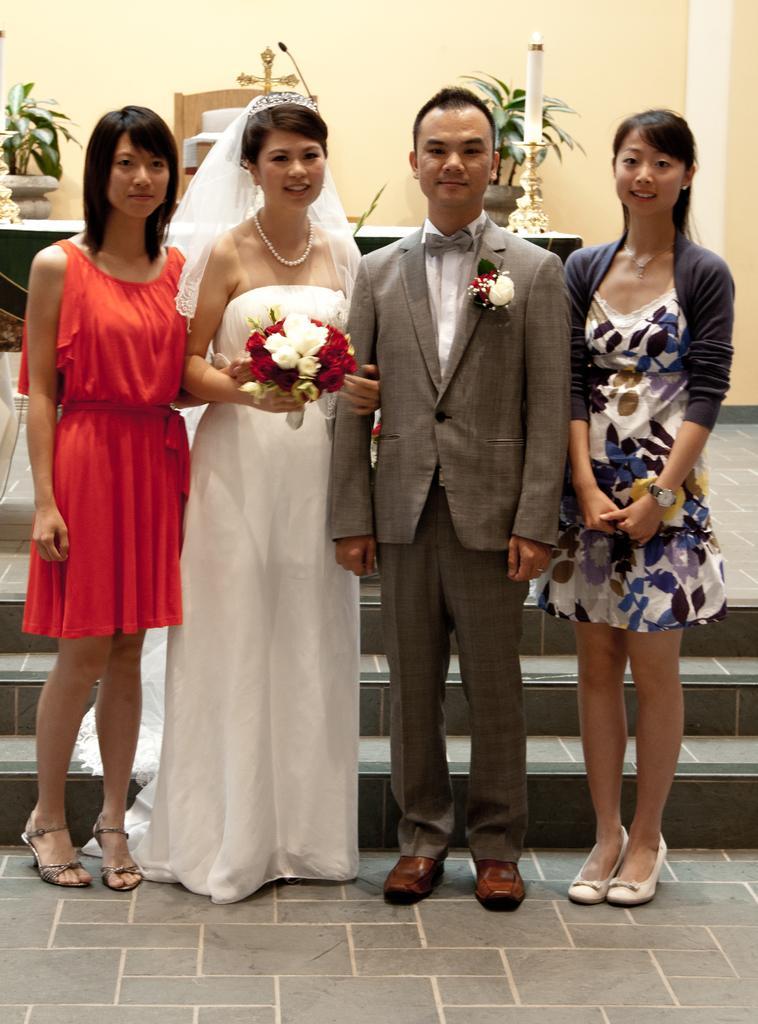How would you summarize this image in a sentence or two? In this four people are standing. In the middle a couple is standing. The man is wearing grey suit. The lady is wearing white gown. She is holding a bouquet. In the background on a table there is a candle on a stand, cross,mic. In the background there are plant pots. Here there are stairs. 